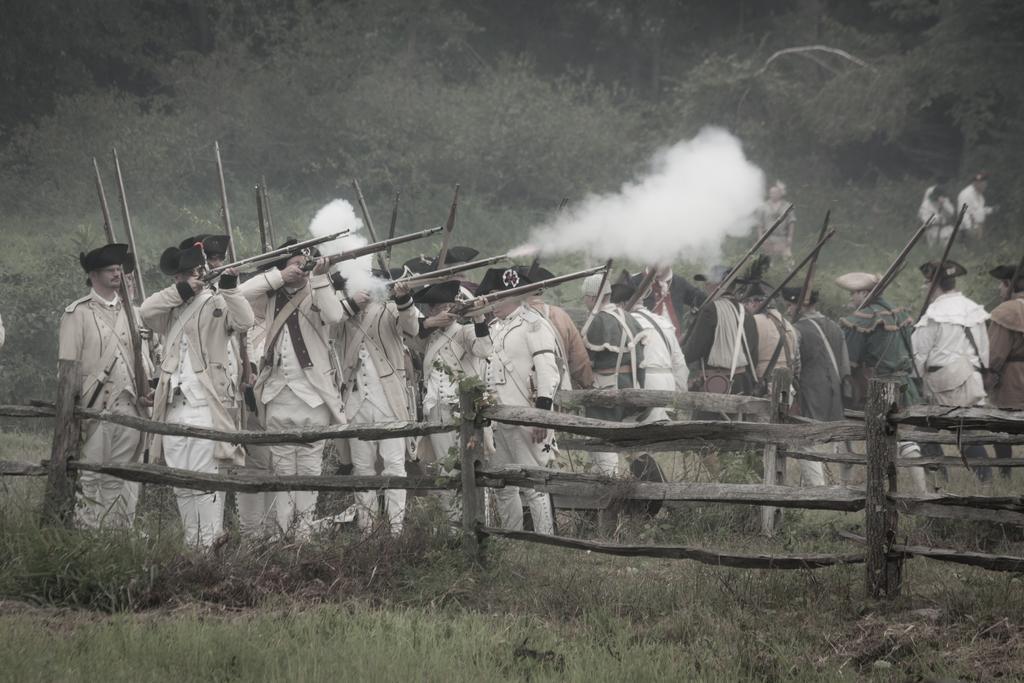Describe this image in one or two sentences. In this image there are few people holding guns in their hands and standing on the surface of the grass, in front of them there is a wooden fence. In the background there are trees. 